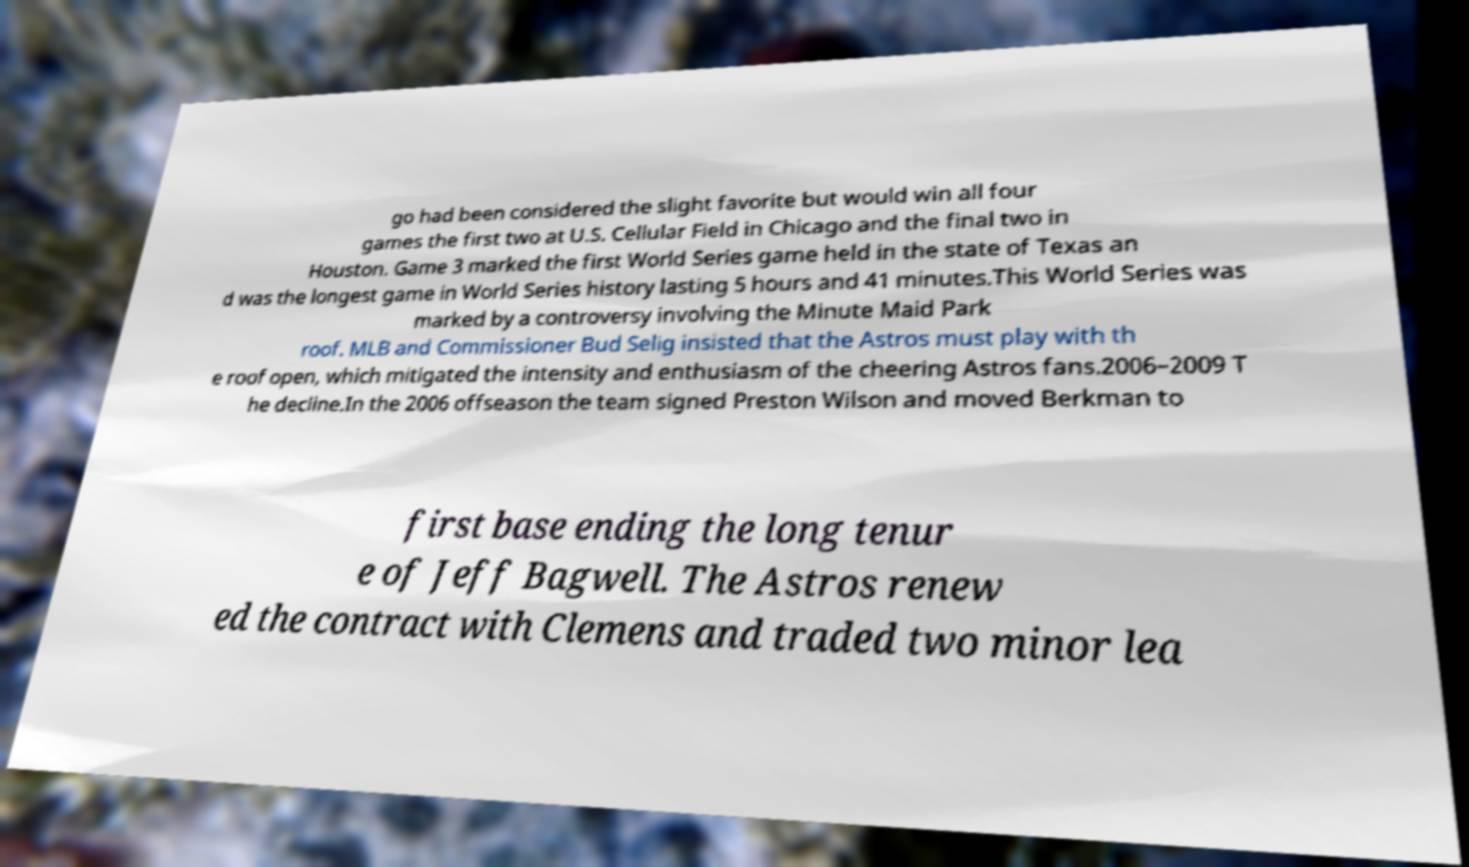For documentation purposes, I need the text within this image transcribed. Could you provide that? go had been considered the slight favorite but would win all four games the first two at U.S. Cellular Field in Chicago and the final two in Houston. Game 3 marked the first World Series game held in the state of Texas an d was the longest game in World Series history lasting 5 hours and 41 minutes.This World Series was marked by a controversy involving the Minute Maid Park roof. MLB and Commissioner Bud Selig insisted that the Astros must play with th e roof open, which mitigated the intensity and enthusiasm of the cheering Astros fans.2006–2009 T he decline.In the 2006 offseason the team signed Preston Wilson and moved Berkman to first base ending the long tenur e of Jeff Bagwell. The Astros renew ed the contract with Clemens and traded two minor lea 